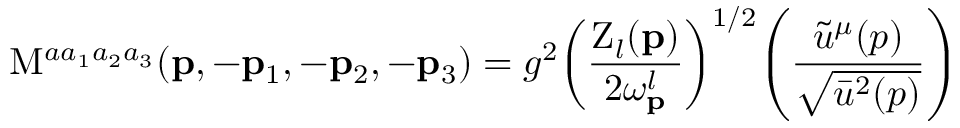<formula> <loc_0><loc_0><loc_500><loc_500>M ^ { a a _ { 1 } a _ { 2 } a _ { 3 } } ( { p } , - { p } _ { 1 } , - { p } _ { 2 } , - { p } _ { 3 } ) = g ^ { 2 } \, \left ( \frac { Z _ { l } ( { p } ) } { 2 \omega _ { p } ^ { l } } \right ) ^ { 1 / 2 } \, \left ( \frac { \tilde { u } ^ { \mu } ( p ) } { \sqrt { \bar { u } ^ { 2 } ( p ) } } \right )</formula> 